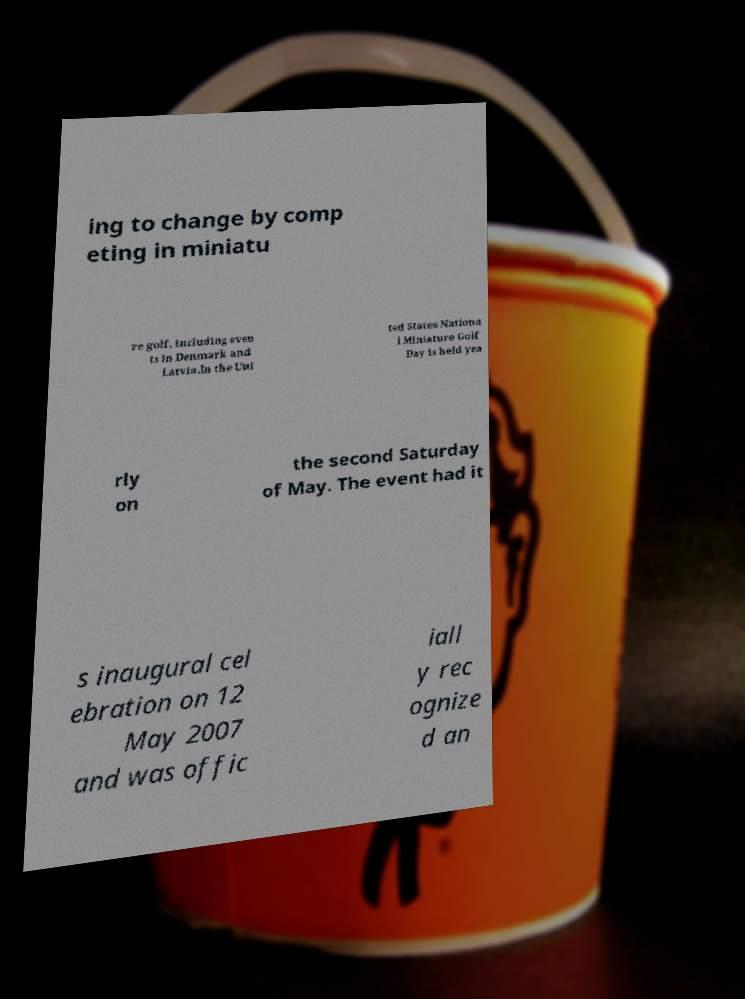I need the written content from this picture converted into text. Can you do that? ing to change by comp eting in miniatu re golf, including even ts in Denmark and Latvia.In the Uni ted States Nationa l Miniature Golf Day is held yea rly on the second Saturday of May. The event had it s inaugural cel ebration on 12 May 2007 and was offic iall y rec ognize d an 